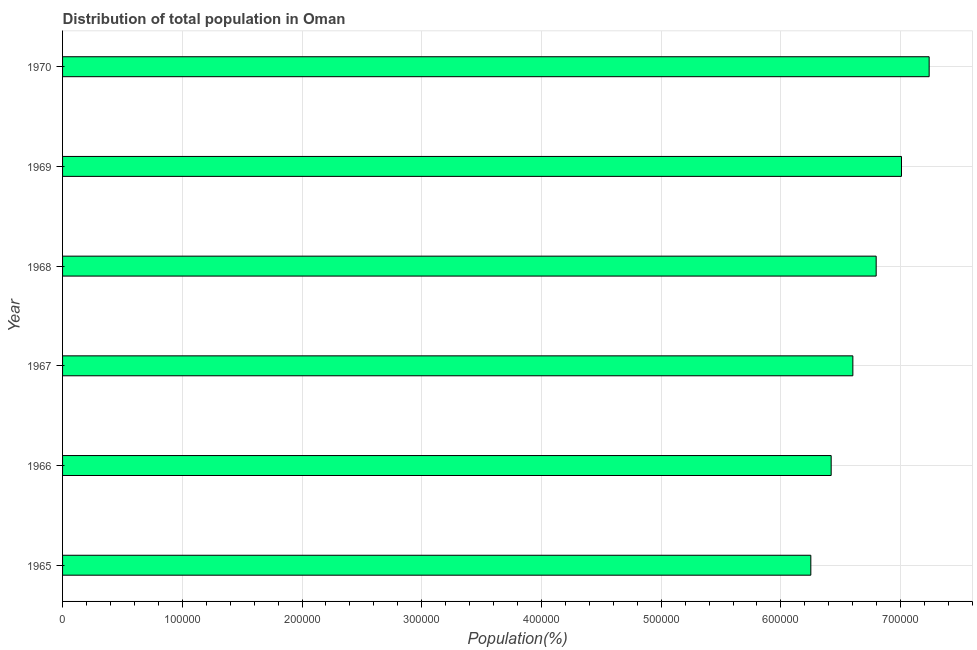Does the graph contain grids?
Make the answer very short. Yes. What is the title of the graph?
Ensure brevity in your answer.  Distribution of total population in Oman . What is the label or title of the X-axis?
Your answer should be very brief. Population(%). What is the population in 1969?
Provide a succinct answer. 7.01e+05. Across all years, what is the maximum population?
Keep it short and to the point. 7.24e+05. Across all years, what is the minimum population?
Your response must be concise. 6.25e+05. In which year was the population maximum?
Your response must be concise. 1970. In which year was the population minimum?
Your answer should be compact. 1965. What is the sum of the population?
Your response must be concise. 4.03e+06. What is the difference between the population in 1968 and 1970?
Offer a very short reply. -4.43e+04. What is the average population per year?
Provide a succinct answer. 6.72e+05. What is the median population?
Keep it short and to the point. 6.70e+05. In how many years, is the population greater than 320000 %?
Keep it short and to the point. 6. Do a majority of the years between 1965 and 1969 (inclusive) have population greater than 640000 %?
Provide a succinct answer. Yes. What is the ratio of the population in 1968 to that in 1970?
Your response must be concise. 0.94. Is the difference between the population in 1966 and 1968 greater than the difference between any two years?
Offer a terse response. No. What is the difference between the highest and the second highest population?
Ensure brevity in your answer.  2.31e+04. Is the sum of the population in 1966 and 1967 greater than the maximum population across all years?
Offer a very short reply. Yes. What is the difference between the highest and the lowest population?
Ensure brevity in your answer.  9.88e+04. Are all the bars in the graph horizontal?
Give a very brief answer. Yes. Are the values on the major ticks of X-axis written in scientific E-notation?
Give a very brief answer. No. What is the Population(%) in 1965?
Give a very brief answer. 6.25e+05. What is the Population(%) in 1966?
Your response must be concise. 6.42e+05. What is the Population(%) of 1967?
Offer a terse response. 6.60e+05. What is the Population(%) in 1968?
Keep it short and to the point. 6.80e+05. What is the Population(%) in 1969?
Your answer should be compact. 7.01e+05. What is the Population(%) of 1970?
Offer a very short reply. 7.24e+05. What is the difference between the Population(%) in 1965 and 1966?
Offer a terse response. -1.70e+04. What is the difference between the Population(%) in 1965 and 1967?
Provide a short and direct response. -3.51e+04. What is the difference between the Population(%) in 1965 and 1968?
Ensure brevity in your answer.  -5.46e+04. What is the difference between the Population(%) in 1965 and 1969?
Your answer should be very brief. -7.57e+04. What is the difference between the Population(%) in 1965 and 1970?
Provide a short and direct response. -9.88e+04. What is the difference between the Population(%) in 1966 and 1967?
Keep it short and to the point. -1.81e+04. What is the difference between the Population(%) in 1966 and 1968?
Provide a succinct answer. -3.76e+04. What is the difference between the Population(%) in 1966 and 1969?
Make the answer very short. -5.87e+04. What is the difference between the Population(%) in 1966 and 1970?
Your answer should be compact. -8.18e+04. What is the difference between the Population(%) in 1967 and 1968?
Give a very brief answer. -1.95e+04. What is the difference between the Population(%) in 1967 and 1969?
Provide a short and direct response. -4.06e+04. What is the difference between the Population(%) in 1967 and 1970?
Provide a short and direct response. -6.37e+04. What is the difference between the Population(%) in 1968 and 1969?
Your response must be concise. -2.11e+04. What is the difference between the Population(%) in 1968 and 1970?
Make the answer very short. -4.43e+04. What is the difference between the Population(%) in 1969 and 1970?
Ensure brevity in your answer.  -2.31e+04. What is the ratio of the Population(%) in 1965 to that in 1966?
Make the answer very short. 0.97. What is the ratio of the Population(%) in 1965 to that in 1967?
Your answer should be very brief. 0.95. What is the ratio of the Population(%) in 1965 to that in 1969?
Provide a short and direct response. 0.89. What is the ratio of the Population(%) in 1965 to that in 1970?
Make the answer very short. 0.86. What is the ratio of the Population(%) in 1966 to that in 1968?
Give a very brief answer. 0.94. What is the ratio of the Population(%) in 1966 to that in 1969?
Make the answer very short. 0.92. What is the ratio of the Population(%) in 1966 to that in 1970?
Keep it short and to the point. 0.89. What is the ratio of the Population(%) in 1967 to that in 1969?
Ensure brevity in your answer.  0.94. What is the ratio of the Population(%) in 1967 to that in 1970?
Offer a terse response. 0.91. What is the ratio of the Population(%) in 1968 to that in 1969?
Offer a terse response. 0.97. What is the ratio of the Population(%) in 1968 to that in 1970?
Your answer should be compact. 0.94. 